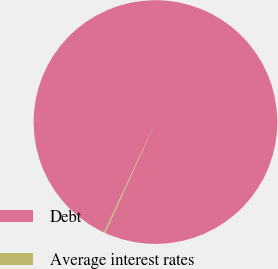Convert chart to OTSL. <chart><loc_0><loc_0><loc_500><loc_500><pie_chart><fcel>Debt<fcel>Average interest rates<nl><fcel>99.81%<fcel>0.19%<nl></chart> 